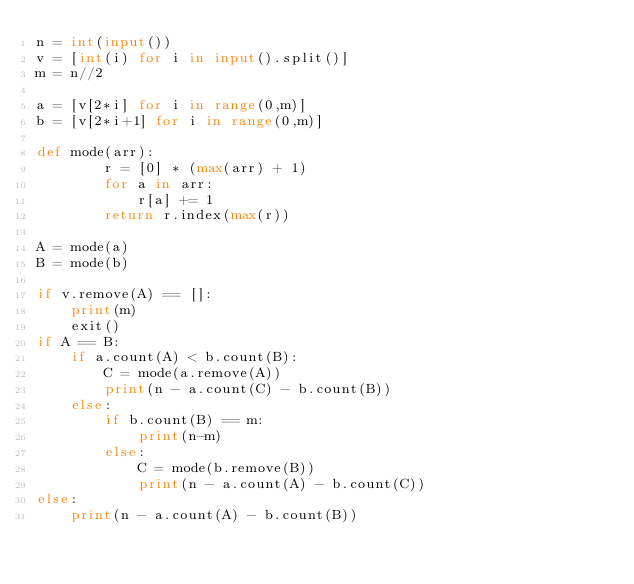<code> <loc_0><loc_0><loc_500><loc_500><_Python_>n = int(input())
v = [int(i) for i in input().split()]
m = n//2

a = [v[2*i] for i in range(0,m)]
b = [v[2*i+1] for i in range(0,m)]

def mode(arr):
        r = [0] * (max(arr) + 1)
        for a in arr:
            r[a] += 1
        return r.index(max(r))

A = mode(a)
B = mode(b)

if v.remove(A) == []:
    print(m)
    exit()
if A == B:
    if a.count(A) < b.count(B):
        C = mode(a.remove(A))
        print(n - a.count(C) - b.count(B))
    else:
        if b.count(B) == m:
            print(n-m)
        else:
            C = mode(b.remove(B))
            print(n - a.count(A) - b.count(C))
else:
    print(n - a.count(A) - b.count(B))</code> 